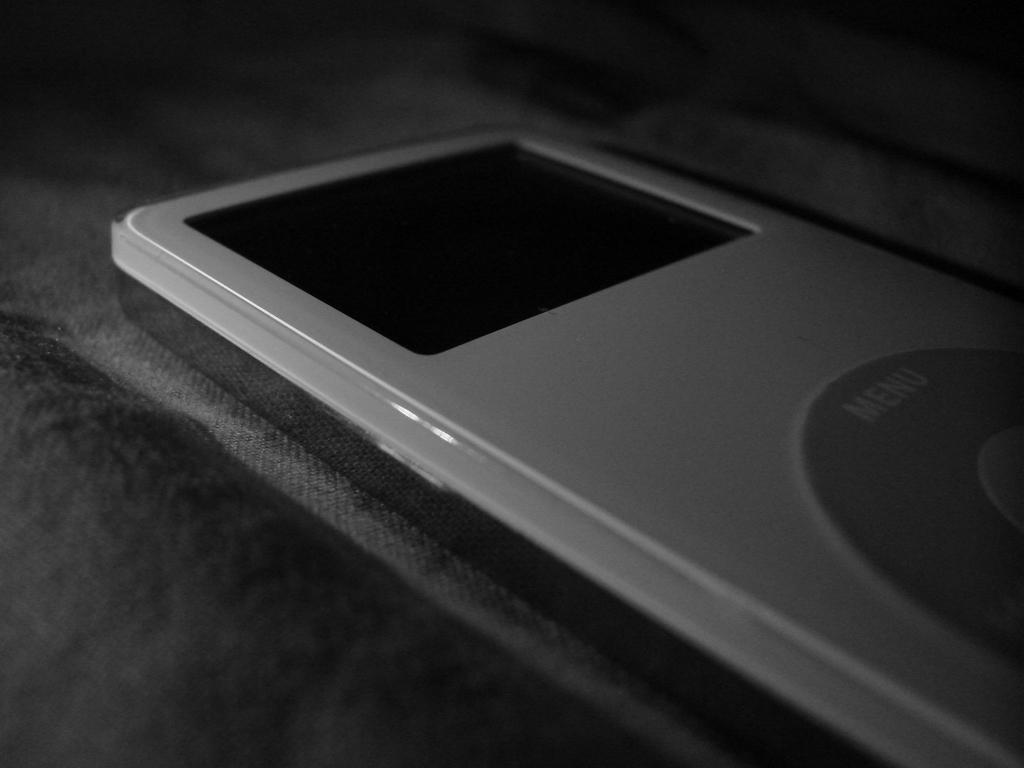What is the color scheme of the image? The image is black and white. What electronic device can be seen in the image? There is an iPod in the image. How would you describe the background of the image? The background of the image is dark. How many clovers are visible in the image? There are no clovers present in the image. What direction is the wind blowing in the image? There is no indication of wind in the image. 